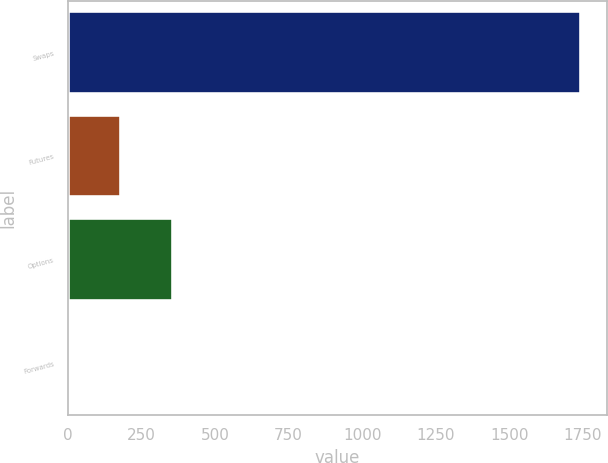Convert chart to OTSL. <chart><loc_0><loc_0><loc_500><loc_500><bar_chart><fcel>Swaps<fcel>Futures<fcel>Options<fcel>Forwards<nl><fcel>1745<fcel>181.7<fcel>355.4<fcel>8<nl></chart> 